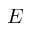Convert formula to latex. <formula><loc_0><loc_0><loc_500><loc_500>E</formula> 